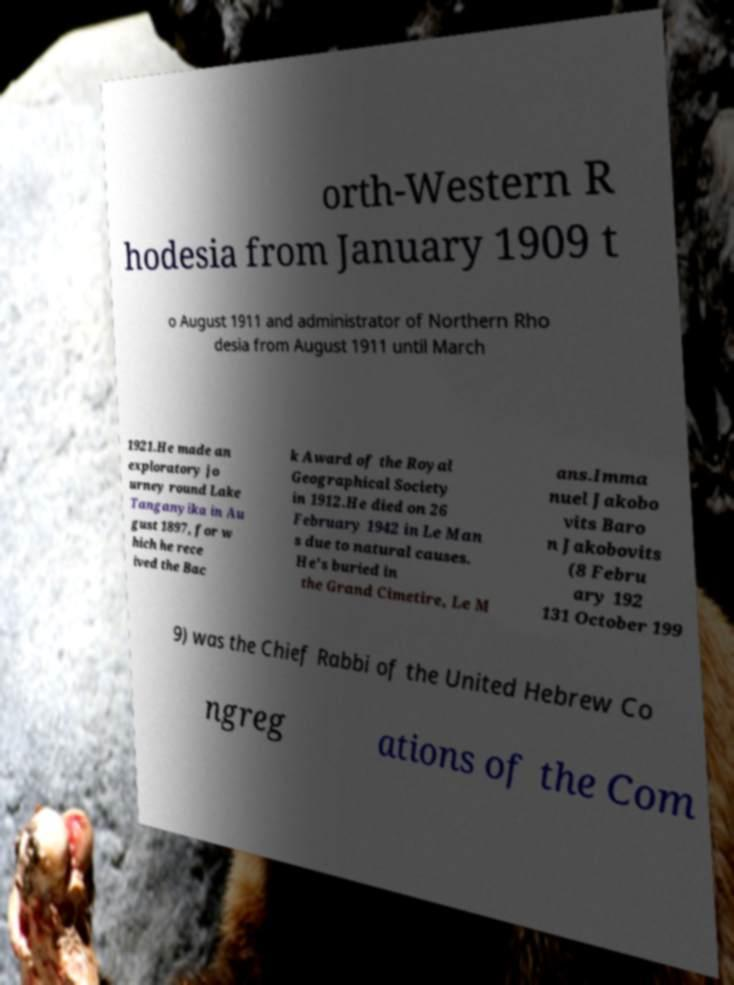There's text embedded in this image that I need extracted. Can you transcribe it verbatim? orth-Western R hodesia from January 1909 t o August 1911 and administrator of Northern Rho desia from August 1911 until March 1921.He made an exploratory jo urney round Lake Tanganyika in Au gust 1897, for w hich he rece ived the Bac k Award of the Royal Geographical Society in 1912.He died on 26 February 1942 in Le Man s due to natural causes. He's buried in the Grand Cimetire, Le M ans.Imma nuel Jakobo vits Baro n Jakobovits (8 Febru ary 192 131 October 199 9) was the Chief Rabbi of the United Hebrew Co ngreg ations of the Com 